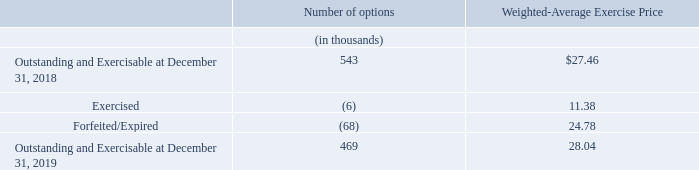Stock Options
The following table summarizes activity involving stock option awards for the year ended December 31, 2019:
The aggregate intrinsic value of our options outstanding and exercisable at December 31, 2019 was less than $1 million. The weighted-average remaining contractual term for such options was 0.18 years.
During 2019, we received net cash proceeds of less than $1 million in connection with our option exercises. The tax benefit realized from these exercises was less than $1 million. The total intrinsic value of options exercised for the years ended December 31, 2019, 2018 and 2017, was less than $1 million each year.
What was the aggregate intrinsic value of options outstanding and exercisable at December 31, 2019?  Less than $1 million. What is the weighted-average remaining contractual term for options outstanding and exercisable? 0.18 years. What are the activity types involving stock option awards? Exercised, forfeited/expired. Which year has a higher weighted-average exercise price for options outstanding and exercisable? 28.04>27.46
Answer: 2019. What is the change in the number of options outstanding and exercisable in 2019 from 2018?
Answer scale should be: thousand. 469-543
Answer: -74. What is the percentage change in the weighted-average exercise price for options outstanding and exercisable in 2019 from 2018?
Answer scale should be: percent. (28.04-27.46)/27.46
Answer: 2.11. 